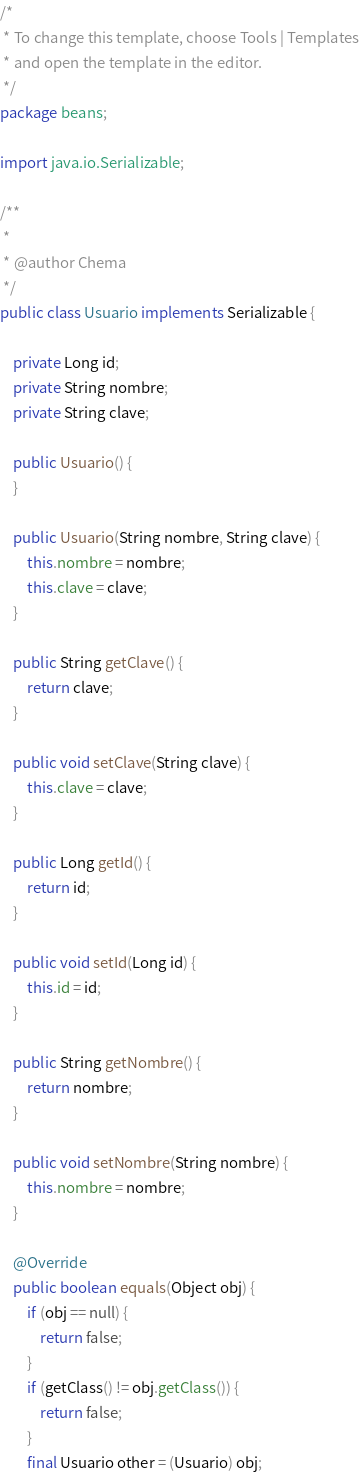Convert code to text. <code><loc_0><loc_0><loc_500><loc_500><_Java_>/*
 * To change this template, choose Tools | Templates
 * and open the template in the editor.
 */
package beans;

import java.io.Serializable;

/**
 *
 * @author Chema
 */
public class Usuario implements Serializable {

    private Long id;
    private String nombre;
    private String clave;

    public Usuario() {
    }

    public Usuario(String nombre, String clave) {
        this.nombre = nombre;
        this.clave = clave;
    }

    public String getClave() {
        return clave;
    }

    public void setClave(String clave) {
        this.clave = clave;
    }

    public Long getId() {
        return id;
    }

    public void setId(Long id) {
        this.id = id;
    }

    public String getNombre() {
        return nombre;
    }

    public void setNombre(String nombre) {
        this.nombre = nombre;
    }

    @Override
    public boolean equals(Object obj) {
        if (obj == null) {
            return false;
        }
        if (getClass() != obj.getClass()) {
            return false;
        }
        final Usuario other = (Usuario) obj;</code> 